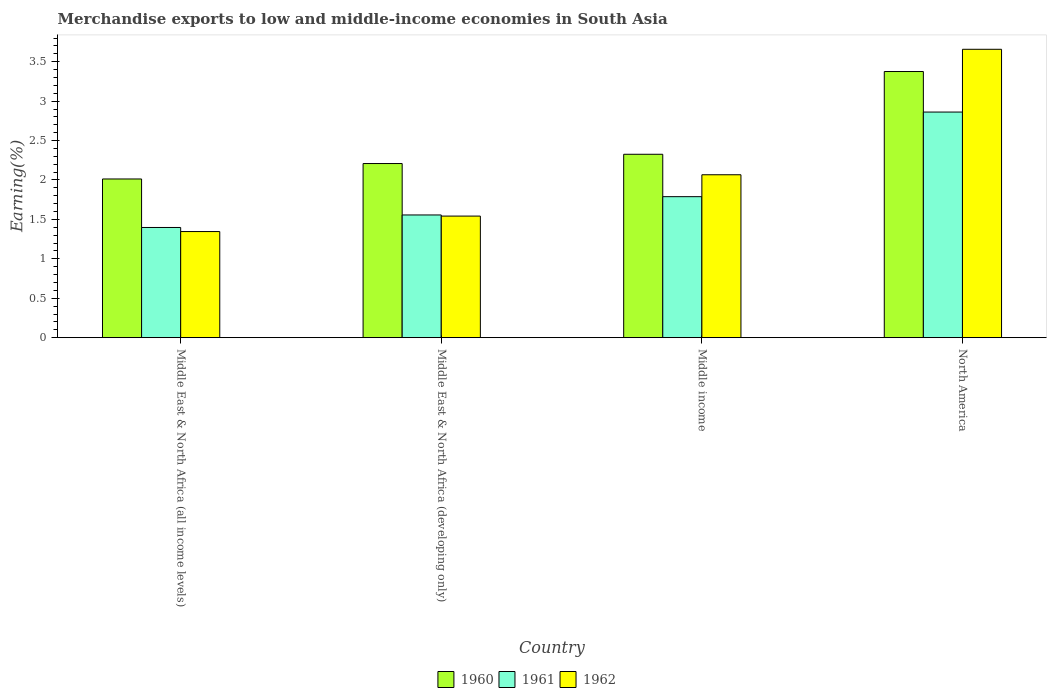How many different coloured bars are there?
Your response must be concise. 3. How many groups of bars are there?
Offer a very short reply. 4. Are the number of bars per tick equal to the number of legend labels?
Provide a short and direct response. Yes. How many bars are there on the 1st tick from the left?
Your response must be concise. 3. In how many cases, is the number of bars for a given country not equal to the number of legend labels?
Your response must be concise. 0. What is the percentage of amount earned from merchandise exports in 1962 in Middle East & North Africa (developing only)?
Provide a succinct answer. 1.54. Across all countries, what is the maximum percentage of amount earned from merchandise exports in 1962?
Offer a terse response. 3.66. Across all countries, what is the minimum percentage of amount earned from merchandise exports in 1962?
Ensure brevity in your answer.  1.35. In which country was the percentage of amount earned from merchandise exports in 1960 minimum?
Provide a succinct answer. Middle East & North Africa (all income levels). What is the total percentage of amount earned from merchandise exports in 1960 in the graph?
Keep it short and to the point. 9.92. What is the difference between the percentage of amount earned from merchandise exports in 1960 in Middle East & North Africa (all income levels) and that in Middle East & North Africa (developing only)?
Keep it short and to the point. -0.2. What is the difference between the percentage of amount earned from merchandise exports in 1960 in Middle income and the percentage of amount earned from merchandise exports in 1962 in North America?
Keep it short and to the point. -1.33. What is the average percentage of amount earned from merchandise exports in 1960 per country?
Offer a very short reply. 2.48. What is the difference between the percentage of amount earned from merchandise exports of/in 1962 and percentage of amount earned from merchandise exports of/in 1960 in North America?
Provide a succinct answer. 0.28. In how many countries, is the percentage of amount earned from merchandise exports in 1960 greater than 2.9 %?
Your answer should be very brief. 1. What is the ratio of the percentage of amount earned from merchandise exports in 1961 in Middle East & North Africa (developing only) to that in North America?
Your response must be concise. 0.54. Is the difference between the percentage of amount earned from merchandise exports in 1962 in Middle East & North Africa (all income levels) and Middle income greater than the difference between the percentage of amount earned from merchandise exports in 1960 in Middle East & North Africa (all income levels) and Middle income?
Offer a very short reply. No. What is the difference between the highest and the second highest percentage of amount earned from merchandise exports in 1960?
Offer a terse response. -1.05. What is the difference between the highest and the lowest percentage of amount earned from merchandise exports in 1962?
Give a very brief answer. 2.31. In how many countries, is the percentage of amount earned from merchandise exports in 1960 greater than the average percentage of amount earned from merchandise exports in 1960 taken over all countries?
Ensure brevity in your answer.  1. What does the 1st bar from the right in Middle income represents?
Give a very brief answer. 1962. Is it the case that in every country, the sum of the percentage of amount earned from merchandise exports in 1960 and percentage of amount earned from merchandise exports in 1961 is greater than the percentage of amount earned from merchandise exports in 1962?
Keep it short and to the point. Yes. Are all the bars in the graph horizontal?
Your answer should be very brief. No. How many countries are there in the graph?
Ensure brevity in your answer.  4. Are the values on the major ticks of Y-axis written in scientific E-notation?
Give a very brief answer. No. Where does the legend appear in the graph?
Offer a very short reply. Bottom center. How many legend labels are there?
Make the answer very short. 3. What is the title of the graph?
Your response must be concise. Merchandise exports to low and middle-income economies in South Asia. Does "2008" appear as one of the legend labels in the graph?
Offer a terse response. No. What is the label or title of the X-axis?
Offer a very short reply. Country. What is the label or title of the Y-axis?
Offer a terse response. Earning(%). What is the Earning(%) of 1960 in Middle East & North Africa (all income levels)?
Ensure brevity in your answer.  2.01. What is the Earning(%) of 1961 in Middle East & North Africa (all income levels)?
Ensure brevity in your answer.  1.4. What is the Earning(%) of 1962 in Middle East & North Africa (all income levels)?
Your answer should be compact. 1.35. What is the Earning(%) in 1960 in Middle East & North Africa (developing only)?
Offer a terse response. 2.21. What is the Earning(%) of 1961 in Middle East & North Africa (developing only)?
Keep it short and to the point. 1.56. What is the Earning(%) in 1962 in Middle East & North Africa (developing only)?
Ensure brevity in your answer.  1.54. What is the Earning(%) in 1960 in Middle income?
Keep it short and to the point. 2.33. What is the Earning(%) in 1961 in Middle income?
Keep it short and to the point. 1.79. What is the Earning(%) of 1962 in Middle income?
Provide a short and direct response. 2.07. What is the Earning(%) in 1960 in North America?
Ensure brevity in your answer.  3.38. What is the Earning(%) in 1961 in North America?
Your answer should be very brief. 2.86. What is the Earning(%) of 1962 in North America?
Provide a succinct answer. 3.66. Across all countries, what is the maximum Earning(%) of 1960?
Your answer should be compact. 3.38. Across all countries, what is the maximum Earning(%) in 1961?
Give a very brief answer. 2.86. Across all countries, what is the maximum Earning(%) in 1962?
Your answer should be very brief. 3.66. Across all countries, what is the minimum Earning(%) in 1960?
Your answer should be compact. 2.01. Across all countries, what is the minimum Earning(%) in 1961?
Ensure brevity in your answer.  1.4. Across all countries, what is the minimum Earning(%) in 1962?
Ensure brevity in your answer.  1.35. What is the total Earning(%) of 1960 in the graph?
Give a very brief answer. 9.92. What is the total Earning(%) of 1961 in the graph?
Make the answer very short. 7.6. What is the total Earning(%) in 1962 in the graph?
Your response must be concise. 8.61. What is the difference between the Earning(%) in 1960 in Middle East & North Africa (all income levels) and that in Middle East & North Africa (developing only)?
Ensure brevity in your answer.  -0.2. What is the difference between the Earning(%) of 1961 in Middle East & North Africa (all income levels) and that in Middle East & North Africa (developing only)?
Provide a short and direct response. -0.16. What is the difference between the Earning(%) in 1962 in Middle East & North Africa (all income levels) and that in Middle East & North Africa (developing only)?
Your answer should be very brief. -0.2. What is the difference between the Earning(%) in 1960 in Middle East & North Africa (all income levels) and that in Middle income?
Offer a terse response. -0.31. What is the difference between the Earning(%) of 1961 in Middle East & North Africa (all income levels) and that in Middle income?
Offer a very short reply. -0.39. What is the difference between the Earning(%) in 1962 in Middle East & North Africa (all income levels) and that in Middle income?
Provide a short and direct response. -0.72. What is the difference between the Earning(%) of 1960 in Middle East & North Africa (all income levels) and that in North America?
Your answer should be compact. -1.36. What is the difference between the Earning(%) in 1961 in Middle East & North Africa (all income levels) and that in North America?
Your answer should be very brief. -1.46. What is the difference between the Earning(%) of 1962 in Middle East & North Africa (all income levels) and that in North America?
Make the answer very short. -2.31. What is the difference between the Earning(%) in 1960 in Middle East & North Africa (developing only) and that in Middle income?
Keep it short and to the point. -0.12. What is the difference between the Earning(%) in 1961 in Middle East & North Africa (developing only) and that in Middle income?
Offer a very short reply. -0.23. What is the difference between the Earning(%) of 1962 in Middle East & North Africa (developing only) and that in Middle income?
Your response must be concise. -0.52. What is the difference between the Earning(%) of 1960 in Middle East & North Africa (developing only) and that in North America?
Your answer should be very brief. -1.17. What is the difference between the Earning(%) of 1961 in Middle East & North Africa (developing only) and that in North America?
Offer a very short reply. -1.31. What is the difference between the Earning(%) in 1962 in Middle East & North Africa (developing only) and that in North America?
Provide a succinct answer. -2.12. What is the difference between the Earning(%) of 1960 in Middle income and that in North America?
Provide a succinct answer. -1.05. What is the difference between the Earning(%) in 1961 in Middle income and that in North America?
Make the answer very short. -1.07. What is the difference between the Earning(%) of 1962 in Middle income and that in North America?
Offer a very short reply. -1.59. What is the difference between the Earning(%) of 1960 in Middle East & North Africa (all income levels) and the Earning(%) of 1961 in Middle East & North Africa (developing only)?
Offer a very short reply. 0.46. What is the difference between the Earning(%) in 1960 in Middle East & North Africa (all income levels) and the Earning(%) in 1962 in Middle East & North Africa (developing only)?
Your response must be concise. 0.47. What is the difference between the Earning(%) in 1961 in Middle East & North Africa (all income levels) and the Earning(%) in 1962 in Middle East & North Africa (developing only)?
Your response must be concise. -0.14. What is the difference between the Earning(%) in 1960 in Middle East & North Africa (all income levels) and the Earning(%) in 1961 in Middle income?
Your answer should be very brief. 0.22. What is the difference between the Earning(%) of 1960 in Middle East & North Africa (all income levels) and the Earning(%) of 1962 in Middle income?
Your response must be concise. -0.05. What is the difference between the Earning(%) in 1961 in Middle East & North Africa (all income levels) and the Earning(%) in 1962 in Middle income?
Provide a short and direct response. -0.67. What is the difference between the Earning(%) in 1960 in Middle East & North Africa (all income levels) and the Earning(%) in 1961 in North America?
Your response must be concise. -0.85. What is the difference between the Earning(%) of 1960 in Middle East & North Africa (all income levels) and the Earning(%) of 1962 in North America?
Offer a very short reply. -1.64. What is the difference between the Earning(%) of 1961 in Middle East & North Africa (all income levels) and the Earning(%) of 1962 in North America?
Your answer should be very brief. -2.26. What is the difference between the Earning(%) of 1960 in Middle East & North Africa (developing only) and the Earning(%) of 1961 in Middle income?
Provide a short and direct response. 0.42. What is the difference between the Earning(%) of 1960 in Middle East & North Africa (developing only) and the Earning(%) of 1962 in Middle income?
Your answer should be compact. 0.14. What is the difference between the Earning(%) of 1961 in Middle East & North Africa (developing only) and the Earning(%) of 1962 in Middle income?
Your answer should be compact. -0.51. What is the difference between the Earning(%) of 1960 in Middle East & North Africa (developing only) and the Earning(%) of 1961 in North America?
Give a very brief answer. -0.65. What is the difference between the Earning(%) in 1960 in Middle East & North Africa (developing only) and the Earning(%) in 1962 in North America?
Ensure brevity in your answer.  -1.45. What is the difference between the Earning(%) of 1961 in Middle East & North Africa (developing only) and the Earning(%) of 1962 in North America?
Provide a succinct answer. -2.1. What is the difference between the Earning(%) of 1960 in Middle income and the Earning(%) of 1961 in North America?
Keep it short and to the point. -0.54. What is the difference between the Earning(%) of 1960 in Middle income and the Earning(%) of 1962 in North America?
Your response must be concise. -1.33. What is the difference between the Earning(%) of 1961 in Middle income and the Earning(%) of 1962 in North America?
Offer a terse response. -1.87. What is the average Earning(%) in 1960 per country?
Provide a succinct answer. 2.48. What is the average Earning(%) of 1961 per country?
Keep it short and to the point. 1.9. What is the average Earning(%) in 1962 per country?
Your answer should be compact. 2.15. What is the difference between the Earning(%) of 1960 and Earning(%) of 1961 in Middle East & North Africa (all income levels)?
Your answer should be compact. 0.62. What is the difference between the Earning(%) of 1960 and Earning(%) of 1962 in Middle East & North Africa (all income levels)?
Your answer should be very brief. 0.67. What is the difference between the Earning(%) in 1961 and Earning(%) in 1962 in Middle East & North Africa (all income levels)?
Offer a terse response. 0.05. What is the difference between the Earning(%) of 1960 and Earning(%) of 1961 in Middle East & North Africa (developing only)?
Your response must be concise. 0.65. What is the difference between the Earning(%) of 1960 and Earning(%) of 1962 in Middle East & North Africa (developing only)?
Keep it short and to the point. 0.67. What is the difference between the Earning(%) in 1961 and Earning(%) in 1962 in Middle East & North Africa (developing only)?
Your answer should be very brief. 0.01. What is the difference between the Earning(%) in 1960 and Earning(%) in 1961 in Middle income?
Your answer should be compact. 0.54. What is the difference between the Earning(%) of 1960 and Earning(%) of 1962 in Middle income?
Keep it short and to the point. 0.26. What is the difference between the Earning(%) of 1961 and Earning(%) of 1962 in Middle income?
Provide a succinct answer. -0.28. What is the difference between the Earning(%) of 1960 and Earning(%) of 1961 in North America?
Your response must be concise. 0.51. What is the difference between the Earning(%) in 1960 and Earning(%) in 1962 in North America?
Make the answer very short. -0.28. What is the difference between the Earning(%) in 1961 and Earning(%) in 1962 in North America?
Provide a succinct answer. -0.8. What is the ratio of the Earning(%) of 1960 in Middle East & North Africa (all income levels) to that in Middle East & North Africa (developing only)?
Provide a short and direct response. 0.91. What is the ratio of the Earning(%) of 1961 in Middle East & North Africa (all income levels) to that in Middle East & North Africa (developing only)?
Make the answer very short. 0.9. What is the ratio of the Earning(%) of 1962 in Middle East & North Africa (all income levels) to that in Middle East & North Africa (developing only)?
Your answer should be very brief. 0.87. What is the ratio of the Earning(%) in 1960 in Middle East & North Africa (all income levels) to that in Middle income?
Keep it short and to the point. 0.87. What is the ratio of the Earning(%) in 1961 in Middle East & North Africa (all income levels) to that in Middle income?
Offer a terse response. 0.78. What is the ratio of the Earning(%) in 1962 in Middle East & North Africa (all income levels) to that in Middle income?
Your answer should be compact. 0.65. What is the ratio of the Earning(%) in 1960 in Middle East & North Africa (all income levels) to that in North America?
Your answer should be very brief. 0.6. What is the ratio of the Earning(%) of 1961 in Middle East & North Africa (all income levels) to that in North America?
Give a very brief answer. 0.49. What is the ratio of the Earning(%) of 1962 in Middle East & North Africa (all income levels) to that in North America?
Give a very brief answer. 0.37. What is the ratio of the Earning(%) of 1960 in Middle East & North Africa (developing only) to that in Middle income?
Offer a terse response. 0.95. What is the ratio of the Earning(%) in 1961 in Middle East & North Africa (developing only) to that in Middle income?
Provide a short and direct response. 0.87. What is the ratio of the Earning(%) in 1962 in Middle East & North Africa (developing only) to that in Middle income?
Give a very brief answer. 0.75. What is the ratio of the Earning(%) of 1960 in Middle East & North Africa (developing only) to that in North America?
Provide a succinct answer. 0.65. What is the ratio of the Earning(%) of 1961 in Middle East & North Africa (developing only) to that in North America?
Your answer should be compact. 0.54. What is the ratio of the Earning(%) in 1962 in Middle East & North Africa (developing only) to that in North America?
Provide a short and direct response. 0.42. What is the ratio of the Earning(%) in 1960 in Middle income to that in North America?
Keep it short and to the point. 0.69. What is the ratio of the Earning(%) in 1961 in Middle income to that in North America?
Your response must be concise. 0.62. What is the ratio of the Earning(%) in 1962 in Middle income to that in North America?
Make the answer very short. 0.56. What is the difference between the highest and the second highest Earning(%) in 1960?
Your answer should be compact. 1.05. What is the difference between the highest and the second highest Earning(%) of 1961?
Your answer should be very brief. 1.07. What is the difference between the highest and the second highest Earning(%) of 1962?
Offer a terse response. 1.59. What is the difference between the highest and the lowest Earning(%) in 1960?
Keep it short and to the point. 1.36. What is the difference between the highest and the lowest Earning(%) of 1961?
Your response must be concise. 1.46. What is the difference between the highest and the lowest Earning(%) of 1962?
Provide a short and direct response. 2.31. 